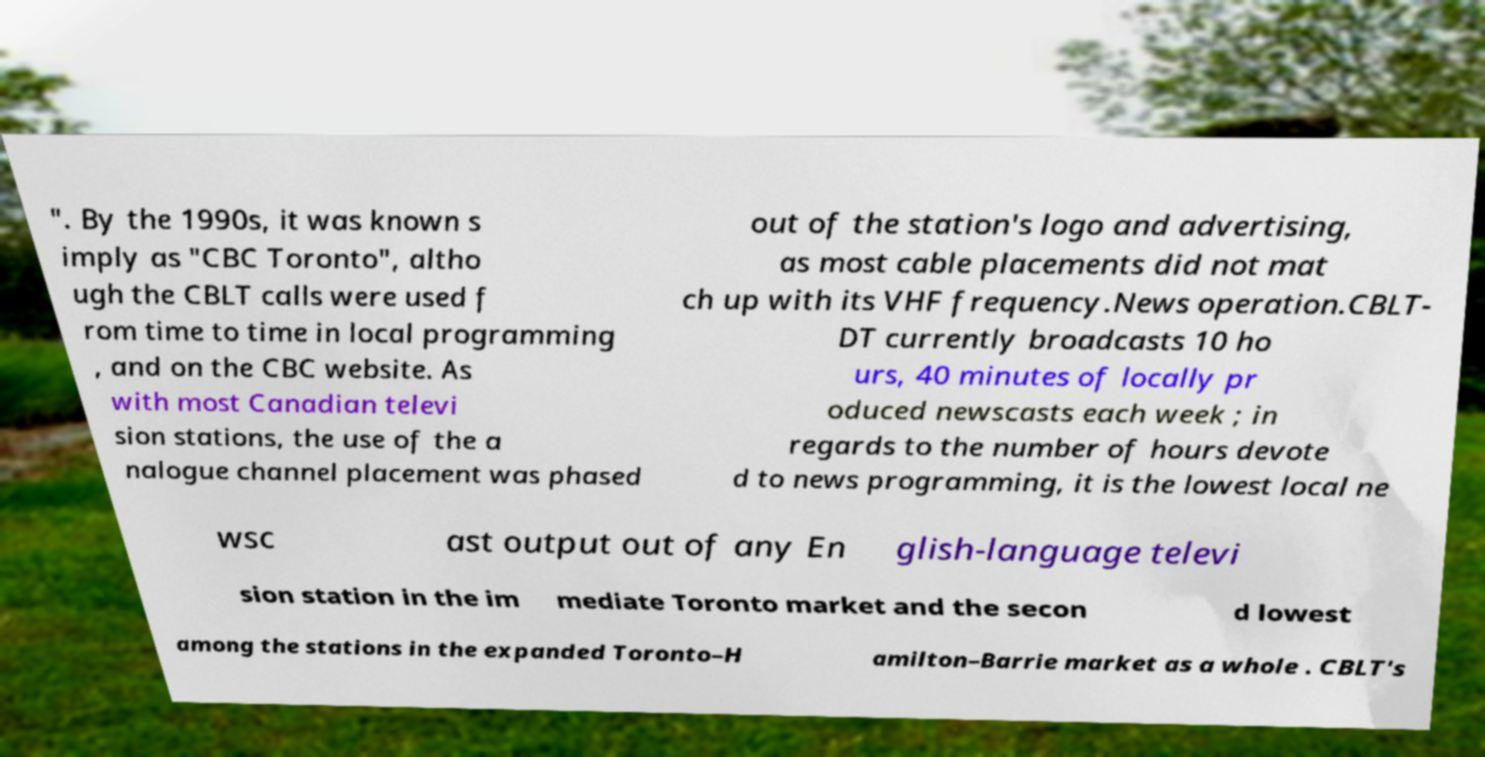For documentation purposes, I need the text within this image transcribed. Could you provide that? ". By the 1990s, it was known s imply as "CBC Toronto", altho ugh the CBLT calls were used f rom time to time in local programming , and on the CBC website. As with most Canadian televi sion stations, the use of the a nalogue channel placement was phased out of the station's logo and advertising, as most cable placements did not mat ch up with its VHF frequency.News operation.CBLT- DT currently broadcasts 10 ho urs, 40 minutes of locally pr oduced newscasts each week ; in regards to the number of hours devote d to news programming, it is the lowest local ne wsc ast output out of any En glish-language televi sion station in the im mediate Toronto market and the secon d lowest among the stations in the expanded Toronto–H amilton–Barrie market as a whole . CBLT's 